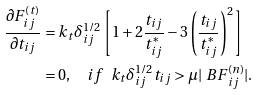<formula> <loc_0><loc_0><loc_500><loc_500>\frac { \partial F ^ { ( t ) } _ { i j } } { \partial t _ { i j } } & = k _ { t } \delta ^ { 1 / 2 } _ { i j } \left [ 1 + 2 \frac { t _ { i j } } { t ^ { * } _ { i j } } - 3 \left ( \frac { t _ { i j } } { t ^ { * } _ { i j } } \right ) ^ { 2 } \right ] \\ & = 0 , \quad i f \ \ k _ { t } \delta ^ { 1 / 2 } _ { i j } t _ { i j } > \mu | { \ B F } ^ { ( n ) } _ { i j } | .</formula> 